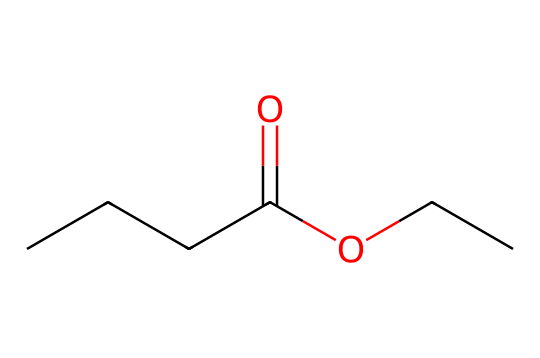What is the chemical name of the compound? The SMILES representation corresponds to ethyl butyrate, which is derived from butyric acid and ethanol. The presence of the ester functional group is evident from the structure.
Answer: ethyl butyrate How many carbon atoms are in this molecule? The SMILES notation shows a straight chain of four carbon atoms in butyrate and two in ethyl, totaling six carbon atoms.
Answer: six What type of functional group is present in this chemical? The structure features a –COO– group, which indicates it is an ester. Esters are characterized by the reaction between an alcohol and a carboxylic acid.
Answer: ester What is the total number of oxygen atoms in this compound? From the structure, there are two oxygen atoms: one in the carbonyl (C=O) and another in the ether (–O–) part of the ester functional group.
Answer: two What kind of taste or smell is related to this ester? Ethyl butyrate is known for its fruity aroma, often described as resembling pineapple or apple. This association is common in flavoring agents used in food products.
Answer: fruity What is the molecular formula of ethyl butyrate? To derive this, you count the atoms from the SMILES notation: C6H12O2 combines to form C6H12O2, which represents the molecular formula of ethyl butyrate.
Answer: C6H12O2 